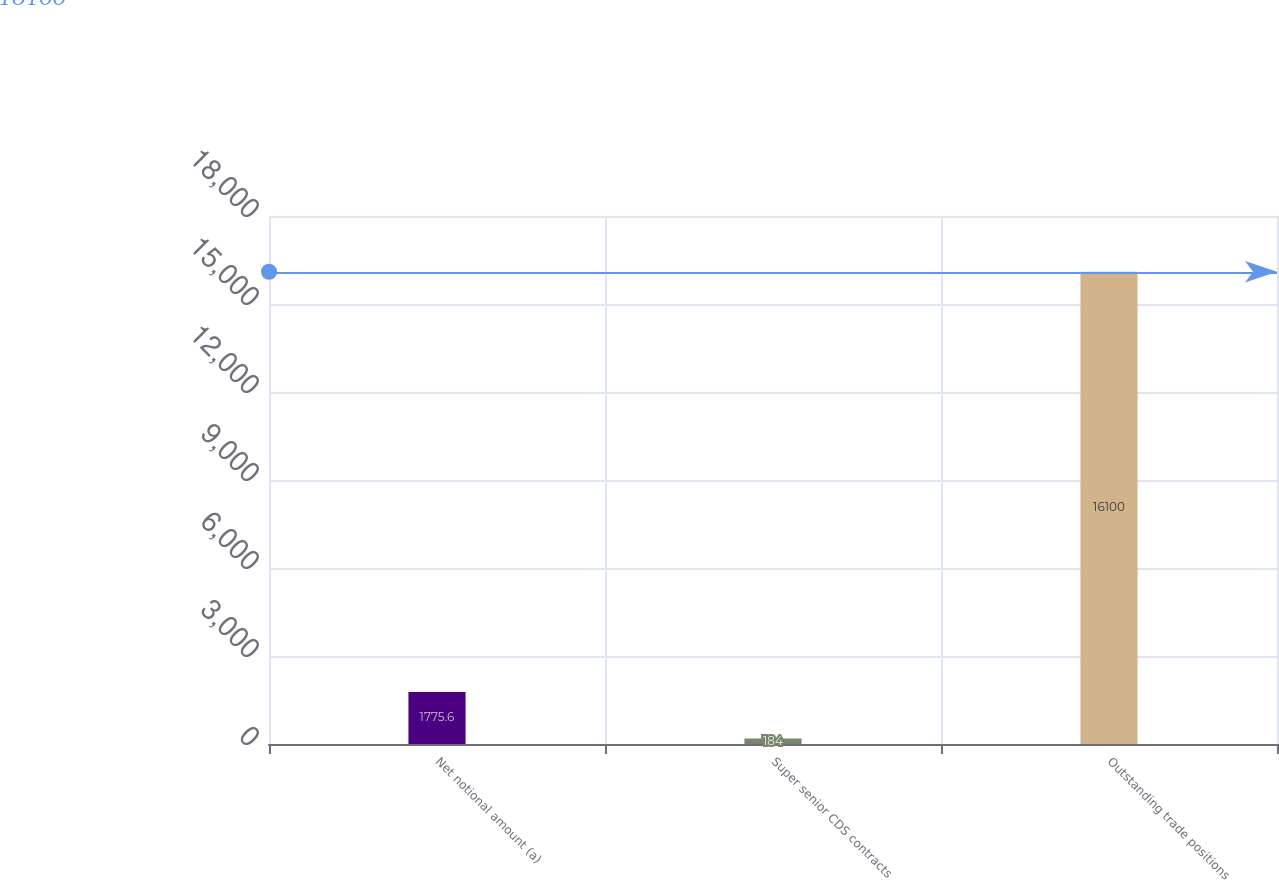Convert chart. <chart><loc_0><loc_0><loc_500><loc_500><bar_chart><fcel>Net notional amount (a)<fcel>Super senior CDS contracts<fcel>Outstanding trade positions<nl><fcel>1775.6<fcel>184<fcel>16100<nl></chart> 